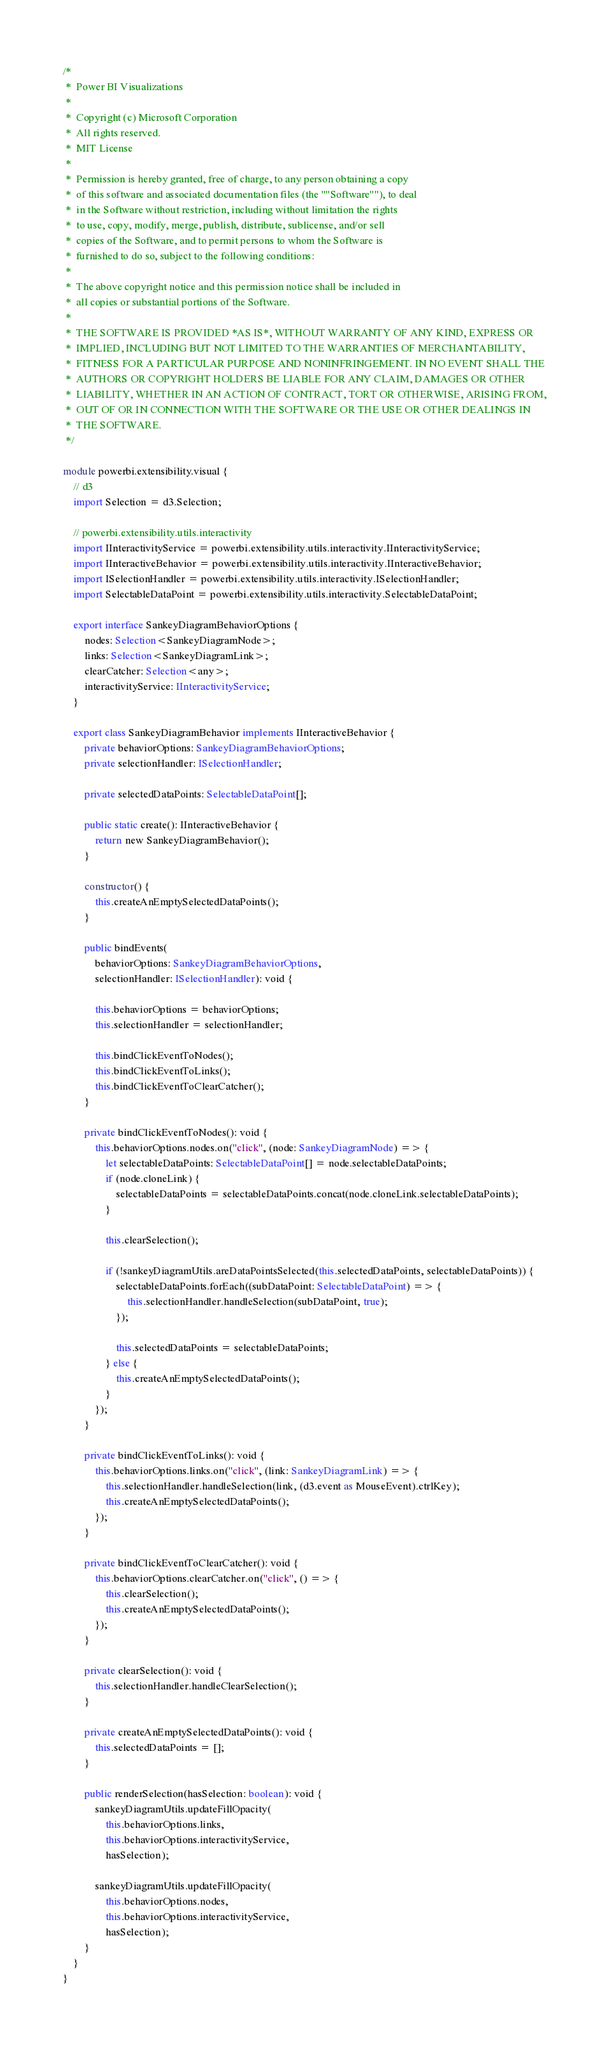Convert code to text. <code><loc_0><loc_0><loc_500><loc_500><_TypeScript_>/*
 *  Power BI Visualizations
 *
 *  Copyright (c) Microsoft Corporation
 *  All rights reserved.
 *  MIT License
 *
 *  Permission is hereby granted, free of charge, to any person obtaining a copy
 *  of this software and associated documentation files (the ""Software""), to deal
 *  in the Software without restriction, including without limitation the rights
 *  to use, copy, modify, merge, publish, distribute, sublicense, and/or sell
 *  copies of the Software, and to permit persons to whom the Software is
 *  furnished to do so, subject to the following conditions:
 *
 *  The above copyright notice and this permission notice shall be included in
 *  all copies or substantial portions of the Software.
 *
 *  THE SOFTWARE IS PROVIDED *AS IS*, WITHOUT WARRANTY OF ANY KIND, EXPRESS OR
 *  IMPLIED, INCLUDING BUT NOT LIMITED TO THE WARRANTIES OF MERCHANTABILITY,
 *  FITNESS FOR A PARTICULAR PURPOSE AND NONINFRINGEMENT. IN NO EVENT SHALL THE
 *  AUTHORS OR COPYRIGHT HOLDERS BE LIABLE FOR ANY CLAIM, DAMAGES OR OTHER
 *  LIABILITY, WHETHER IN AN ACTION OF CONTRACT, TORT OR OTHERWISE, ARISING FROM,
 *  OUT OF OR IN CONNECTION WITH THE SOFTWARE OR THE USE OR OTHER DEALINGS IN
 *  THE SOFTWARE.
 */

module powerbi.extensibility.visual {
    // d3
    import Selection = d3.Selection;

    // powerbi.extensibility.utils.interactivity
    import IInteractivityService = powerbi.extensibility.utils.interactivity.IInteractivityService;
    import IInteractiveBehavior = powerbi.extensibility.utils.interactivity.IInteractiveBehavior;
    import ISelectionHandler = powerbi.extensibility.utils.interactivity.ISelectionHandler;
    import SelectableDataPoint = powerbi.extensibility.utils.interactivity.SelectableDataPoint;

    export interface SankeyDiagramBehaviorOptions {
        nodes: Selection<SankeyDiagramNode>;
        links: Selection<SankeyDiagramLink>;
        clearCatcher: Selection<any>;
        interactivityService: IInteractivityService;
    }

    export class SankeyDiagramBehavior implements IInteractiveBehavior {
        private behaviorOptions: SankeyDiagramBehaviorOptions;
        private selectionHandler: ISelectionHandler;

        private selectedDataPoints: SelectableDataPoint[];

        public static create(): IInteractiveBehavior {
            return new SankeyDiagramBehavior();
        }

        constructor() {
            this.createAnEmptySelectedDataPoints();
        }

        public bindEvents(
            behaviorOptions: SankeyDiagramBehaviorOptions,
            selectionHandler: ISelectionHandler): void {

            this.behaviorOptions = behaviorOptions;
            this.selectionHandler = selectionHandler;

            this.bindClickEventToNodes();
            this.bindClickEventToLinks();
            this.bindClickEventToClearCatcher();
        }

        private bindClickEventToNodes(): void {
            this.behaviorOptions.nodes.on("click", (node: SankeyDiagramNode) => {
                let selectableDataPoints: SelectableDataPoint[] = node.selectableDataPoints;
                if (node.cloneLink) {
                    selectableDataPoints = selectableDataPoints.concat(node.cloneLink.selectableDataPoints);
                }

                this.clearSelection();

                if (!sankeyDiagramUtils.areDataPointsSelected(this.selectedDataPoints, selectableDataPoints)) {
                    selectableDataPoints.forEach((subDataPoint: SelectableDataPoint) => {
                        this.selectionHandler.handleSelection(subDataPoint, true);
                    });

                    this.selectedDataPoints = selectableDataPoints;
                } else {
                    this.createAnEmptySelectedDataPoints();
                }
            });
        }

        private bindClickEventToLinks(): void {
            this.behaviorOptions.links.on("click", (link: SankeyDiagramLink) => {
                this.selectionHandler.handleSelection(link, (d3.event as MouseEvent).ctrlKey);
                this.createAnEmptySelectedDataPoints();
            });
        }

        private bindClickEventToClearCatcher(): void {
            this.behaviorOptions.clearCatcher.on("click", () => {
                this.clearSelection();
                this.createAnEmptySelectedDataPoints();
            });
        }

        private clearSelection(): void {
            this.selectionHandler.handleClearSelection();
        }

        private createAnEmptySelectedDataPoints(): void {
            this.selectedDataPoints = [];
        }

        public renderSelection(hasSelection: boolean): void {
            sankeyDiagramUtils.updateFillOpacity(
                this.behaviorOptions.links,
                this.behaviorOptions.interactivityService,
                hasSelection);

            sankeyDiagramUtils.updateFillOpacity(
                this.behaviorOptions.nodes,
                this.behaviorOptions.interactivityService,
                hasSelection);
        }
    }
}
</code> 